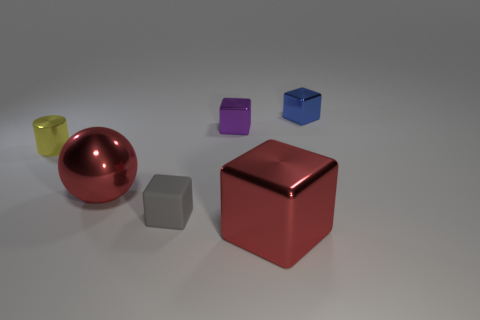Subtract 0 cyan spheres. How many objects are left? 6 Subtract all cylinders. How many objects are left? 5 Subtract 2 blocks. How many blocks are left? 2 Subtract all brown cylinders. Subtract all green balls. How many cylinders are left? 1 Subtract all gray spheres. How many brown blocks are left? 0 Subtract all green balls. Subtract all purple objects. How many objects are left? 5 Add 4 gray matte things. How many gray matte things are left? 5 Add 6 big blue shiny blocks. How many big blue shiny blocks exist? 6 Add 3 small brown metallic cylinders. How many objects exist? 9 Subtract all blue blocks. How many blocks are left? 3 